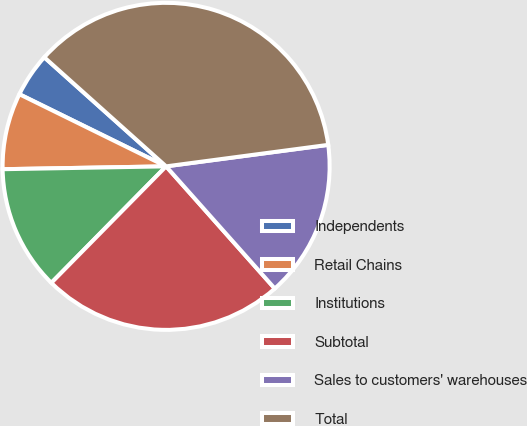<chart> <loc_0><loc_0><loc_500><loc_500><pie_chart><fcel>Independents<fcel>Retail Chains<fcel>Institutions<fcel>Subtotal<fcel>Sales to customers' warehouses<fcel>Total<nl><fcel>4.35%<fcel>7.55%<fcel>12.34%<fcel>23.95%<fcel>15.53%<fcel>36.28%<nl></chart> 